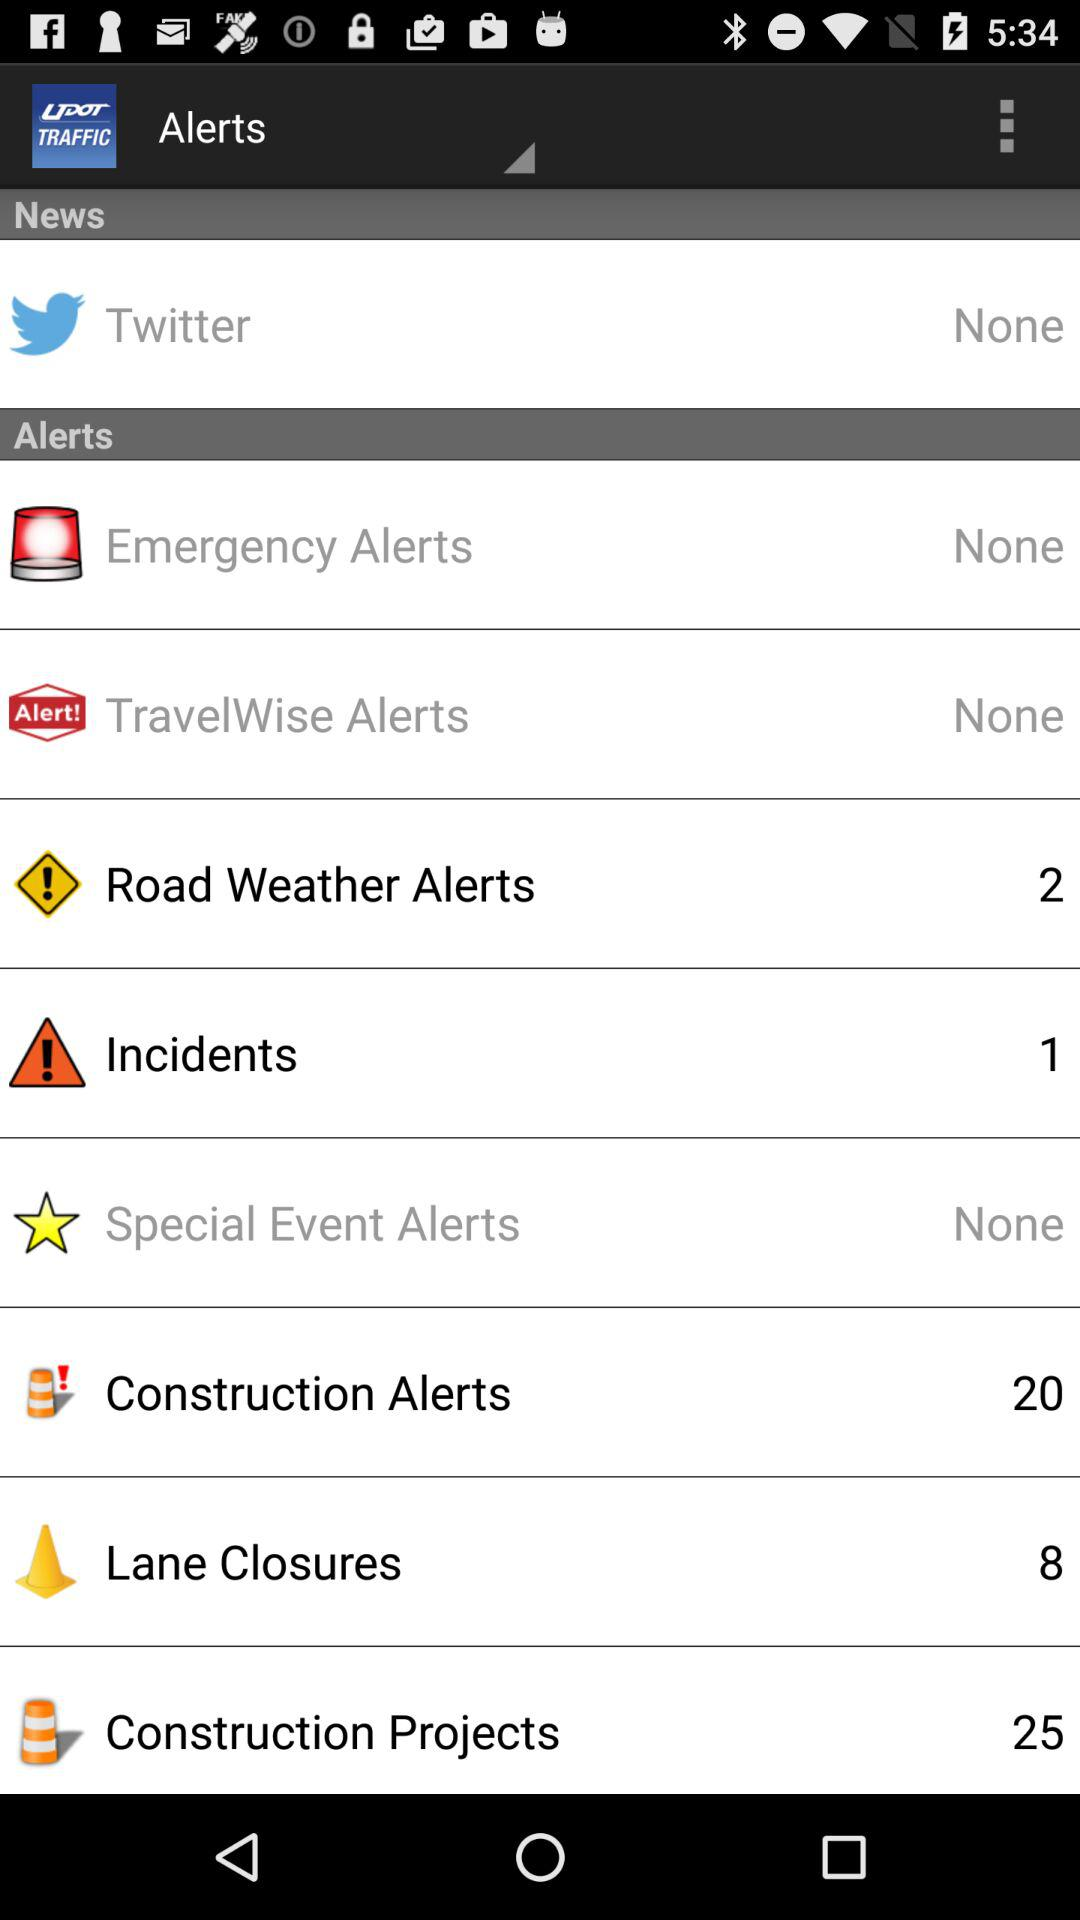How many "Incidents" alerts are there? There is 1 "Incidents" alert. 